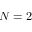Convert formula to latex. <formula><loc_0><loc_0><loc_500><loc_500>N = 2</formula> 